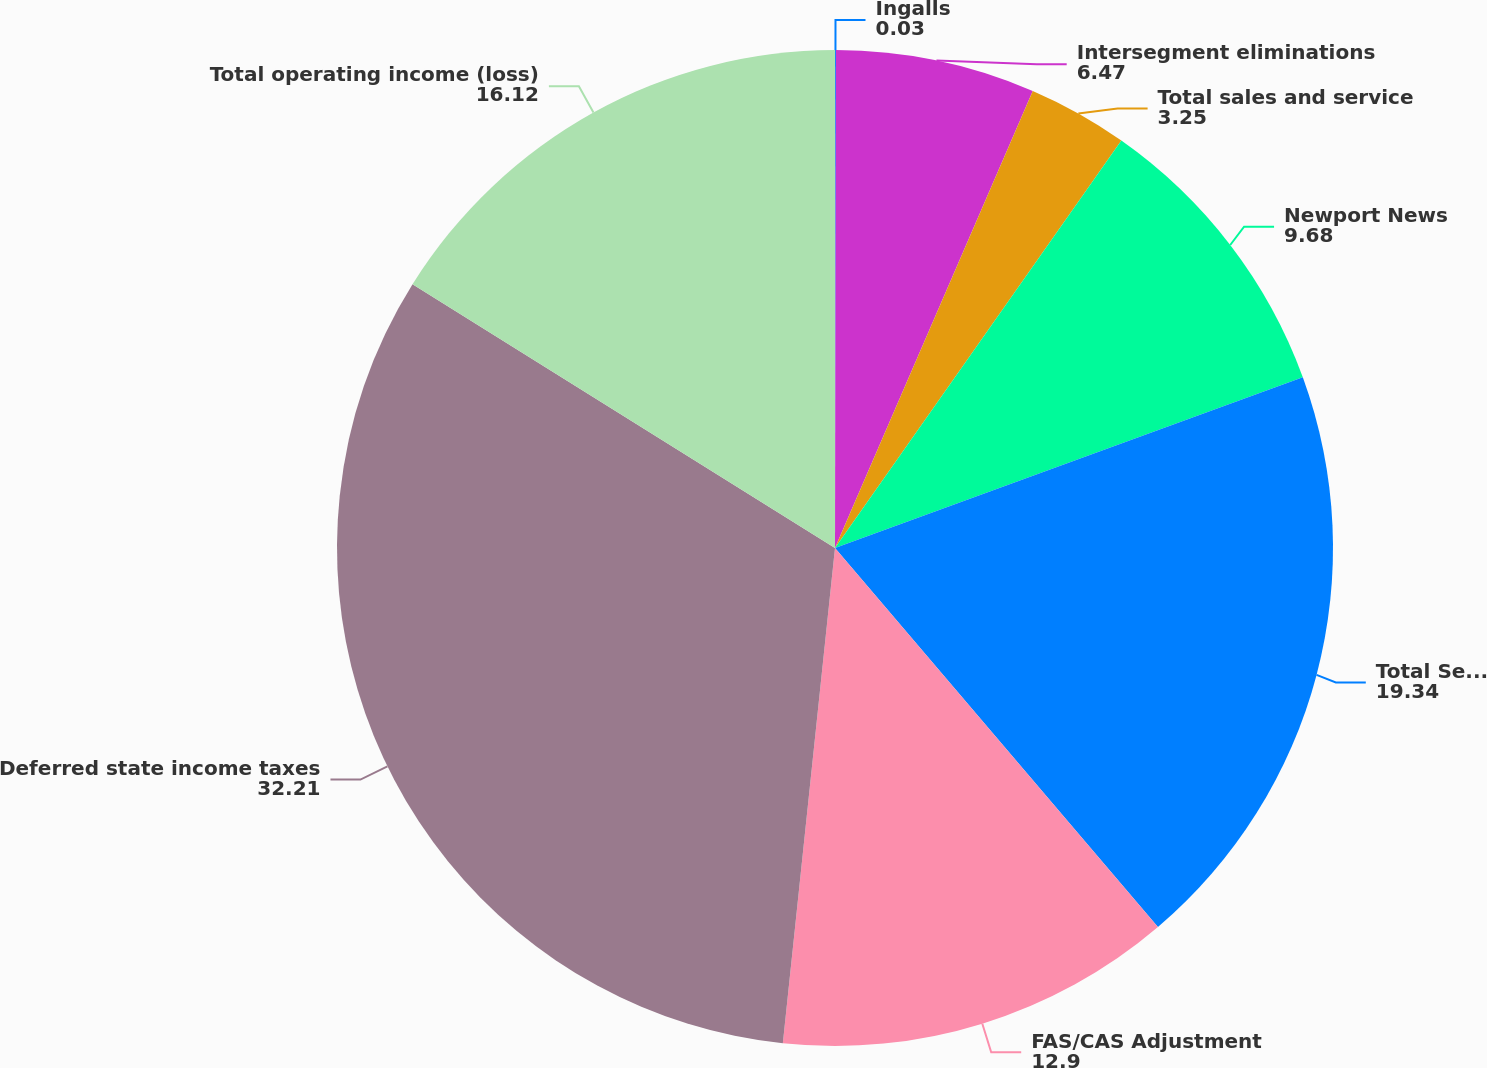<chart> <loc_0><loc_0><loc_500><loc_500><pie_chart><fcel>Ingalls<fcel>Intersegment eliminations<fcel>Total sales and service<fcel>Newport News<fcel>Total Segment Operating Income<fcel>FAS/CAS Adjustment<fcel>Deferred state income taxes<fcel>Total operating income (loss)<nl><fcel>0.03%<fcel>6.47%<fcel>3.25%<fcel>9.68%<fcel>19.34%<fcel>12.9%<fcel>32.21%<fcel>16.12%<nl></chart> 